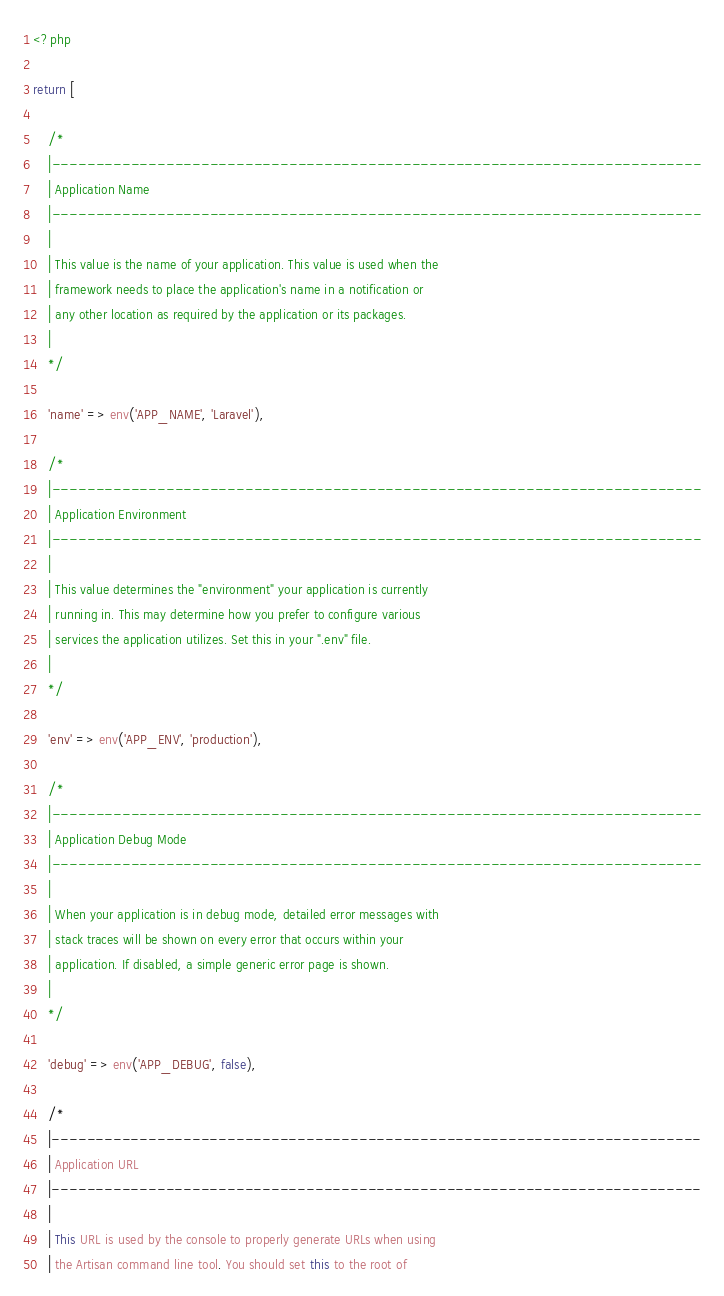<code> <loc_0><loc_0><loc_500><loc_500><_PHP_><?php

return [

    /*
    |--------------------------------------------------------------------------
    | Application Name
    |--------------------------------------------------------------------------
    |
    | This value is the name of your application. This value is used when the
    | framework needs to place the application's name in a notification or
    | any other location as required by the application or its packages.
    |
    */

    'name' => env('APP_NAME', 'Laravel'),

    /*
    |--------------------------------------------------------------------------
    | Application Environment
    |--------------------------------------------------------------------------
    |
    | This value determines the "environment" your application is currently
    | running in. This may determine how you prefer to configure various
    | services the application utilizes. Set this in your ".env" file.
    |
    */

    'env' => env('APP_ENV', 'production'),

    /*
    |--------------------------------------------------------------------------
    | Application Debug Mode
    |--------------------------------------------------------------------------
    |
    | When your application is in debug mode, detailed error messages with
    | stack traces will be shown on every error that occurs within your
    | application. If disabled, a simple generic error page is shown.
    |
    */

    'debug' => env('APP_DEBUG', false),

    /*
    |--------------------------------------------------------------------------
    | Application URL
    |--------------------------------------------------------------------------
    |
    | This URL is used by the console to properly generate URLs when using
    | the Artisan command line tool. You should set this to the root of</code> 